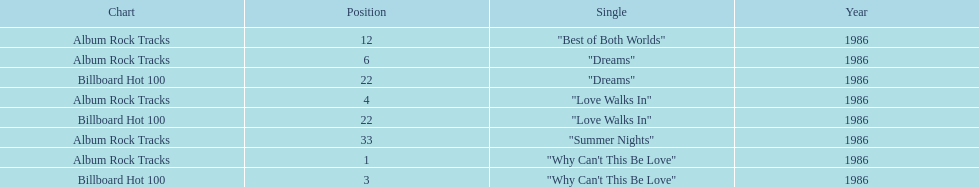Which is the most popular single on the album? Why Can't This Be Love. 